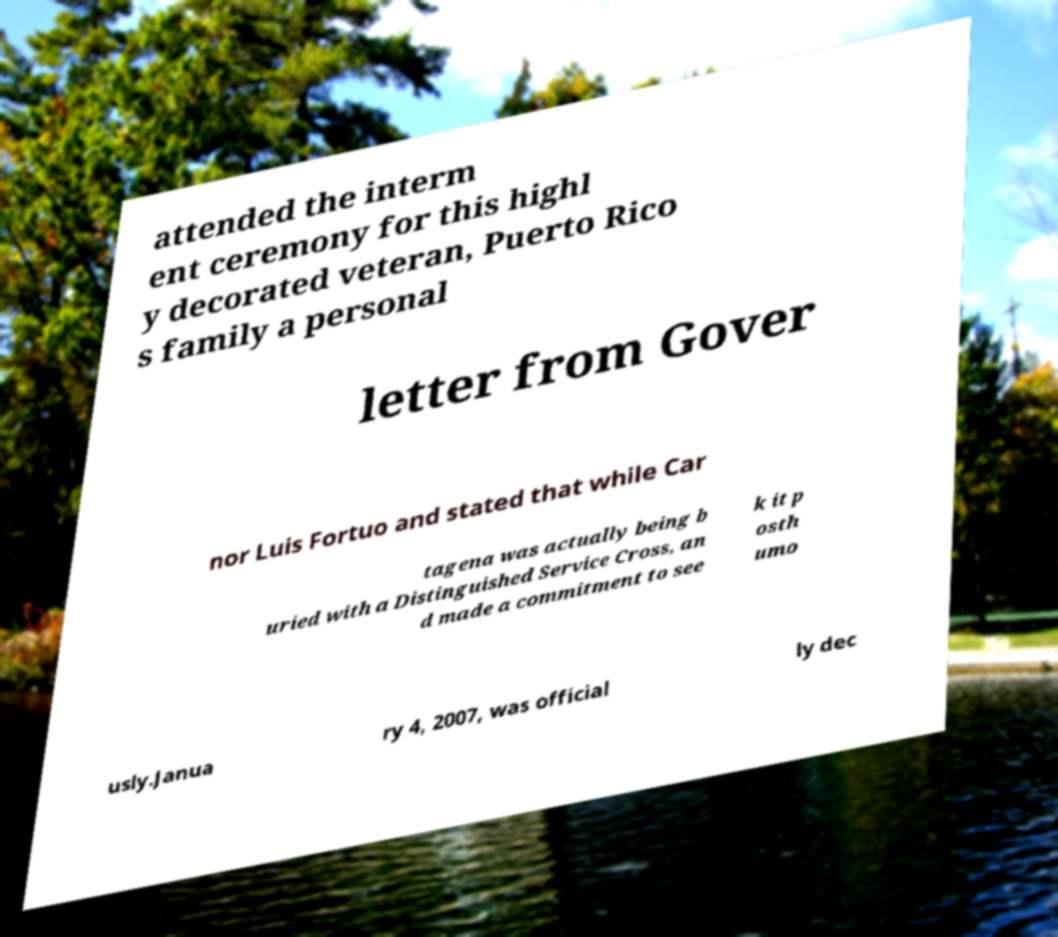Please identify and transcribe the text found in this image. attended the interm ent ceremony for this highl y decorated veteran, Puerto Rico s family a personal letter from Gover nor Luis Fortuo and stated that while Car tagena was actually being b uried with a Distinguished Service Cross, an d made a commitment to see k it p osth umo usly.Janua ry 4, 2007, was official ly dec 